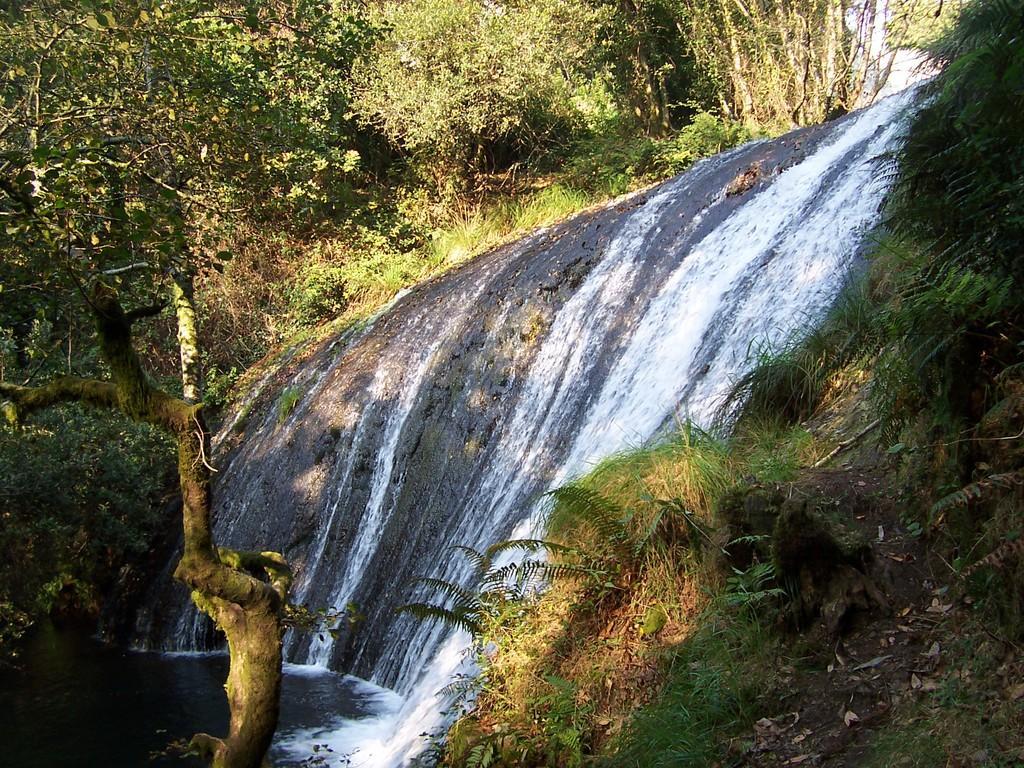Please provide a concise description of this image. In this picture we can see a waterfall and in the background we can see trees. 